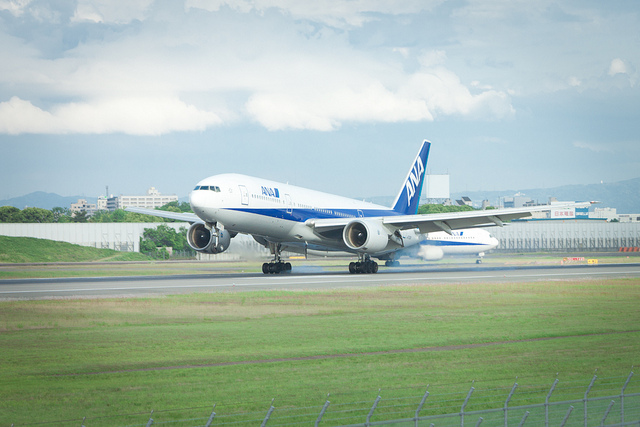Please extract the text content from this image. ANA ANA 